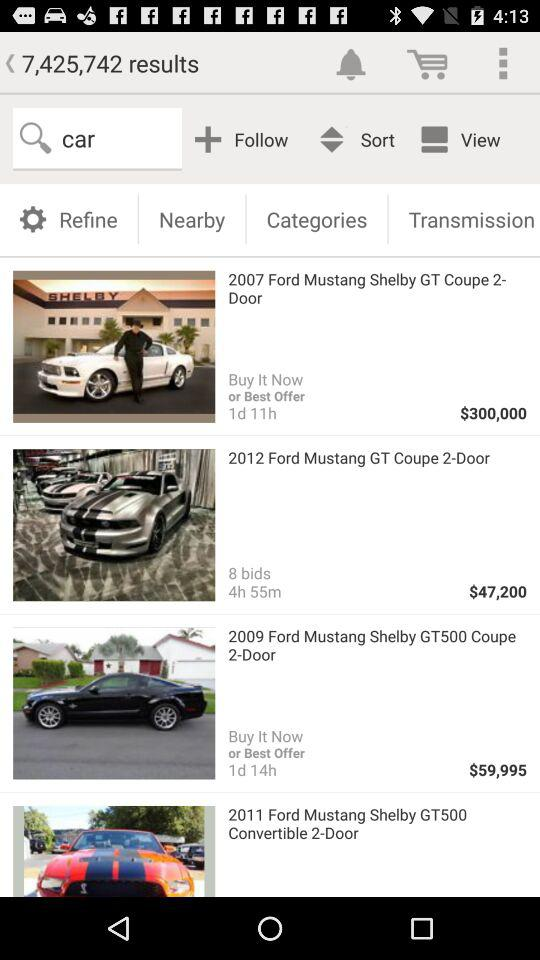What is the remaining time for "2012 Ford Mustang GT Coupe 2-Door"? The remaining time is 4 hours 55 minutes. 